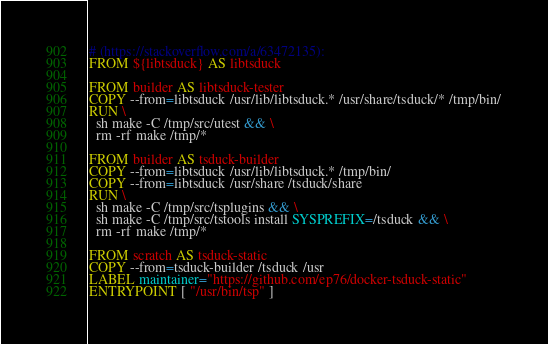Convert code to text. <code><loc_0><loc_0><loc_500><loc_500><_Dockerfile_># (https://stackoverflow.com/a/63472135):
FROM ${libtsduck} AS libtsduck

FROM builder AS libtsduck-tester
COPY --from=libtsduck /usr/lib/libtsduck.* /usr/share/tsduck/* /tmp/bin/
RUN \
  sh make -C /tmp/src/utest && \
  rm -rf make /tmp/*

FROM builder AS tsduck-builder
COPY --from=libtsduck /usr/lib/libtsduck.* /tmp/bin/
COPY --from=libtsduck /usr/share /tsduck/share
RUN \
  sh make -C /tmp/src/tsplugins && \
  sh make -C /tmp/src/tstools install SYSPREFIX=/tsduck && \
  rm -rf make /tmp/*

FROM scratch AS tsduck-static
COPY --from=tsduck-builder /tsduck /usr
LABEL maintainer="https://github.com/ep76/docker-tsduck-static"
ENTRYPOINT [ "/usr/bin/tsp" ]
</code> 